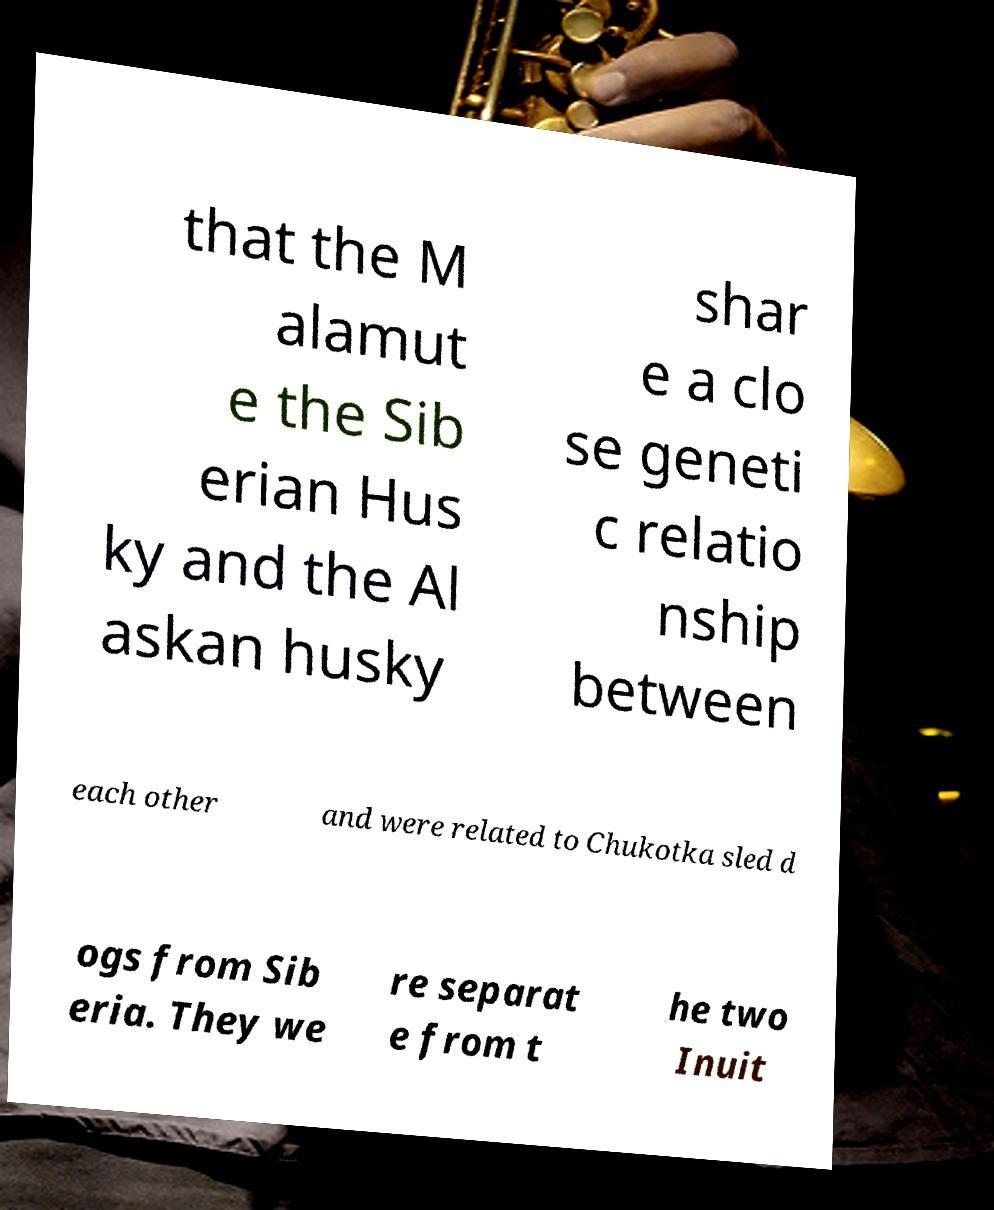I need the written content from this picture converted into text. Can you do that? that the M alamut e the Sib erian Hus ky and the Al askan husky shar e a clo se geneti c relatio nship between each other and were related to Chukotka sled d ogs from Sib eria. They we re separat e from t he two Inuit 